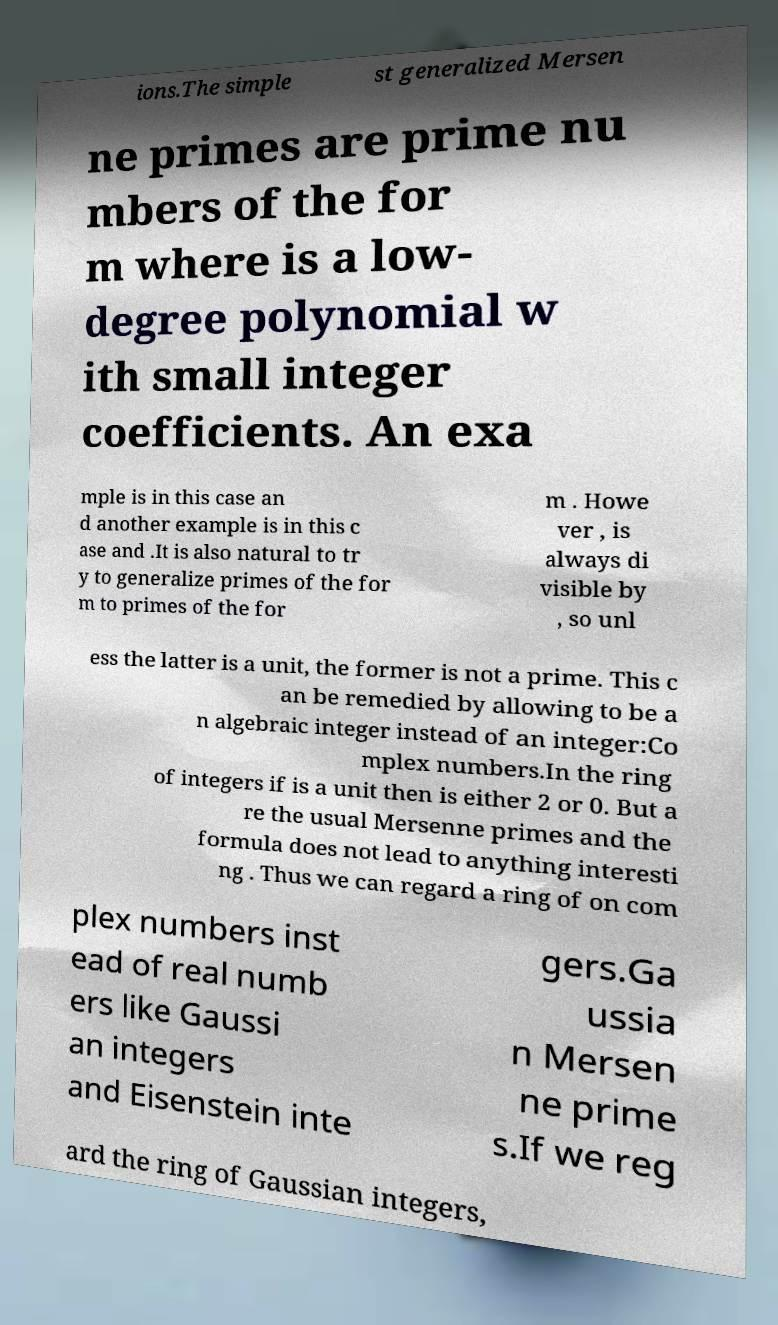Can you read and provide the text displayed in the image?This photo seems to have some interesting text. Can you extract and type it out for me? ions.The simple st generalized Mersen ne primes are prime nu mbers of the for m where is a low- degree polynomial w ith small integer coefficients. An exa mple is in this case an d another example is in this c ase and .It is also natural to tr y to generalize primes of the for m to primes of the for m . Howe ver , is always di visible by , so unl ess the latter is a unit, the former is not a prime. This c an be remedied by allowing to be a n algebraic integer instead of an integer:Co mplex numbers.In the ring of integers if is a unit then is either 2 or 0. But a re the usual Mersenne primes and the formula does not lead to anything interesti ng . Thus we can regard a ring of on com plex numbers inst ead of real numb ers like Gaussi an integers and Eisenstein inte gers.Ga ussia n Mersen ne prime s.If we reg ard the ring of Gaussian integers, 